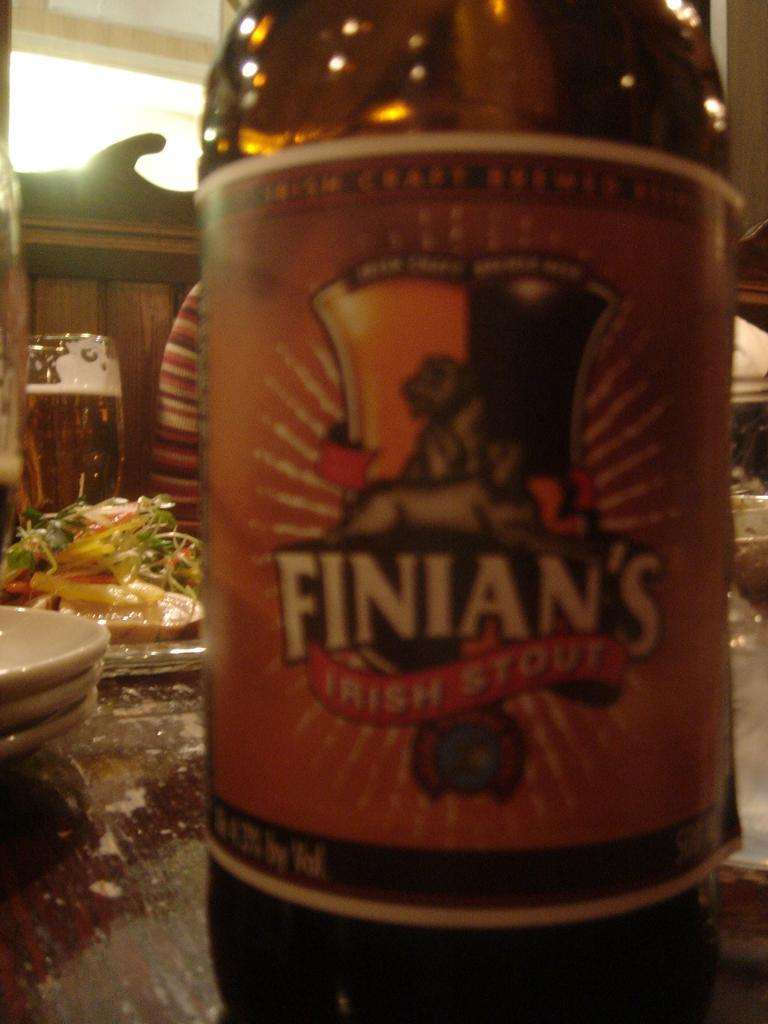<image>
Write a terse but informative summary of the picture. A bottle of Finian's Irish Stout contains 4.2 percent alcohol by volume. 